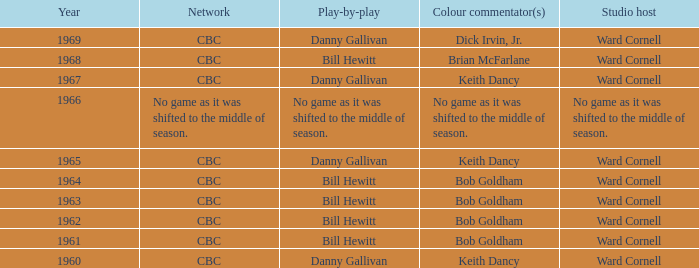Who gave the play by play commentary with studio host Ward Cornell? Danny Gallivan, Bill Hewitt, Danny Gallivan, Danny Gallivan, Bill Hewitt, Bill Hewitt, Bill Hewitt, Bill Hewitt, Danny Gallivan. 